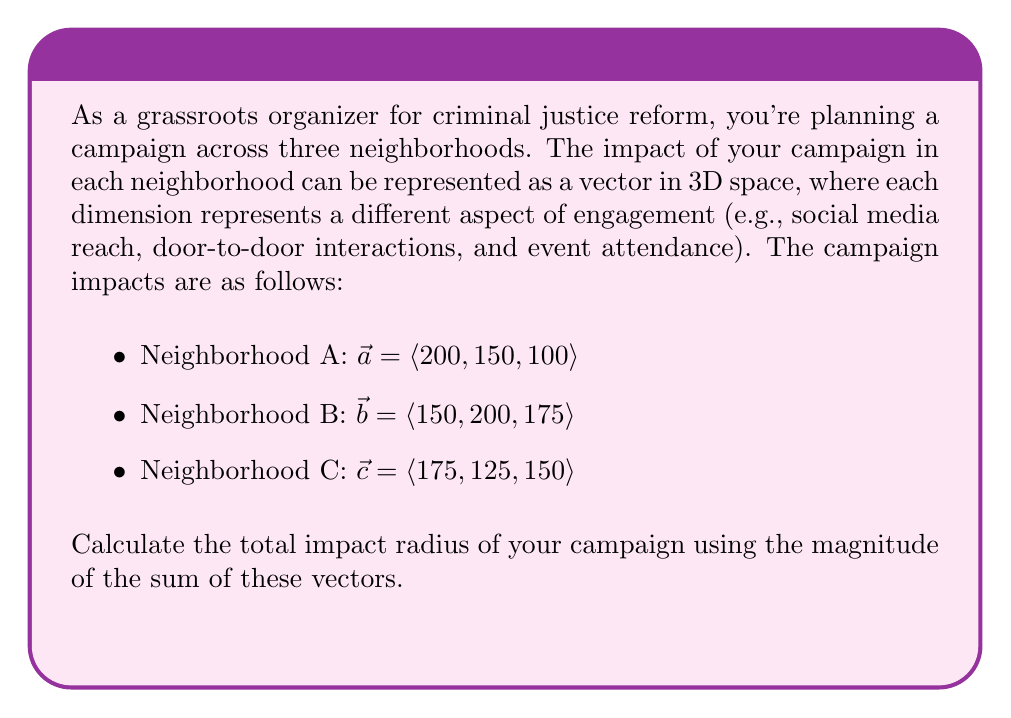What is the answer to this math problem? To solve this problem, we'll follow these steps:

1) First, we need to sum the three vectors:
   $\vec{t} = \vec{a} + \vec{b} + \vec{c}$
   
   $\vec{t} = \langle 200, 150, 100 \rangle + \langle 150, 200, 175 \rangle + \langle 175, 125, 150 \rangle$
   
   $\vec{t} = \langle 200+150+175, 150+200+125, 100+175+150 \rangle$
   
   $\vec{t} = \langle 525, 475, 425 \rangle$

2) Now, we need to calculate the magnitude of this resultant vector. The magnitude of a 3D vector $\vec{v} = \langle x, y, z \rangle$ is given by:

   $\|\vec{v}\| = \sqrt{x^2 + y^2 + z^2}$

3) Applying this to our total impact vector:

   $\|\vec{t}\| = \sqrt{525^2 + 475^2 + 425^2}$

4) Let's calculate:
   
   $\|\vec{t}\| = \sqrt{275625 + 225625 + 180625}$
   
   $\|\vec{t}\| = \sqrt{681875}$
   
   $\|\vec{t}\| \approx 825.76$

5) Therefore, the total impact radius of the campaign is approximately 825.76 units.
Answer: 825.76 units 